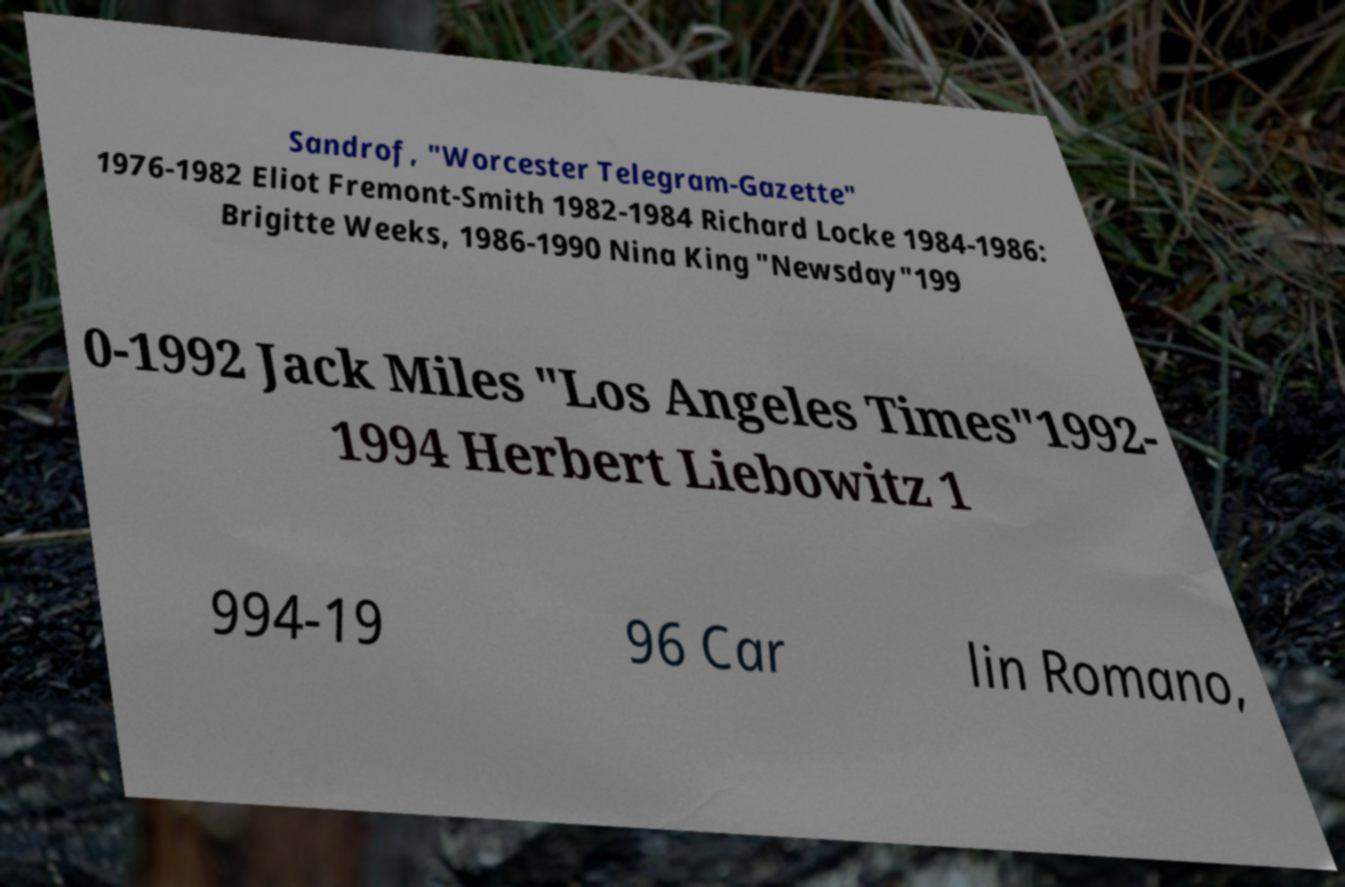Can you accurately transcribe the text from the provided image for me? Sandrof, "Worcester Telegram-Gazette" 1976-1982 Eliot Fremont-Smith 1982-1984 Richard Locke 1984-1986: Brigitte Weeks, 1986-1990 Nina King "Newsday"199 0-1992 Jack Miles "Los Angeles Times"1992- 1994 Herbert Liebowitz 1 994-19 96 Car lin Romano, 